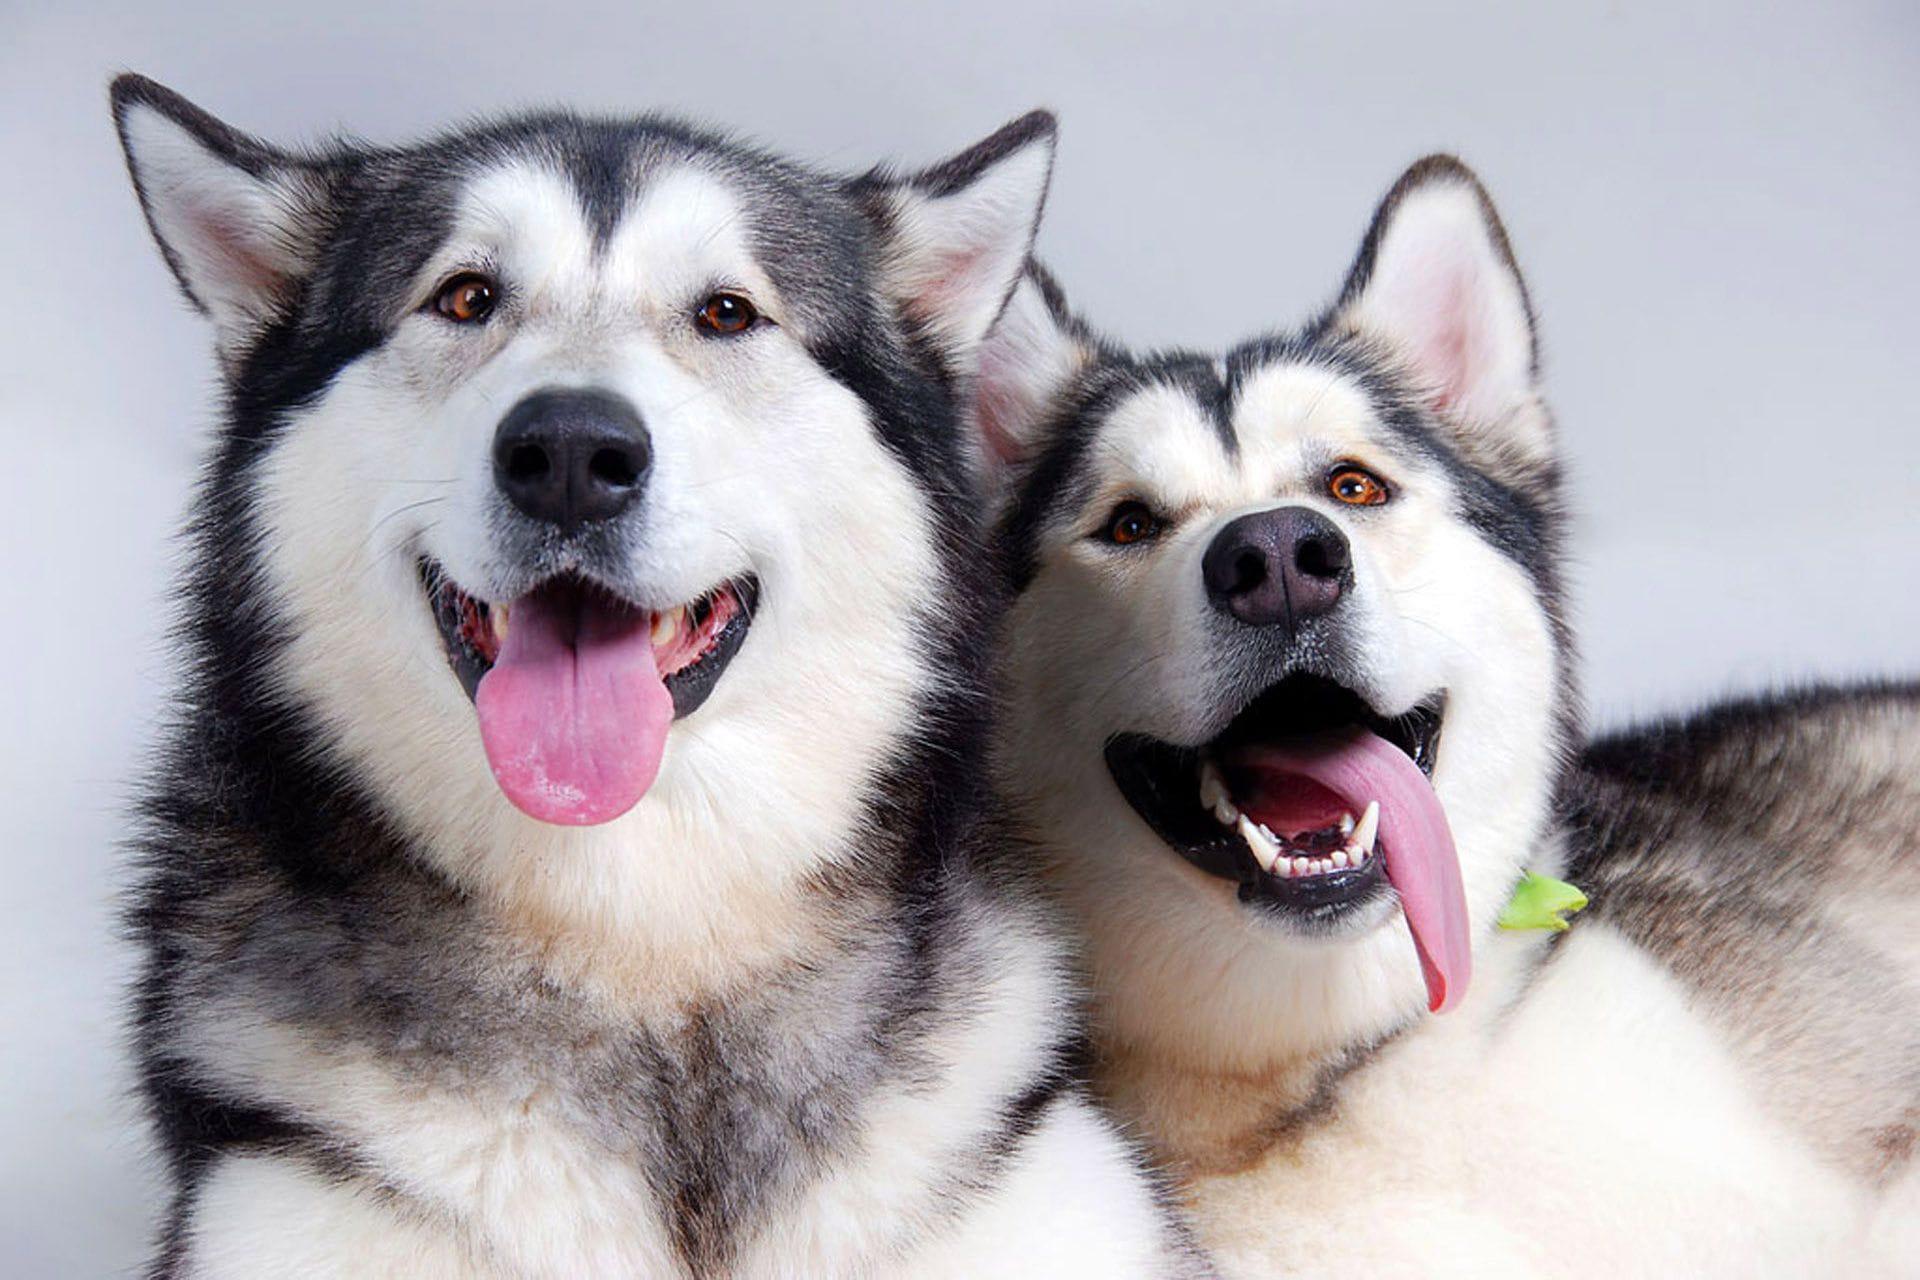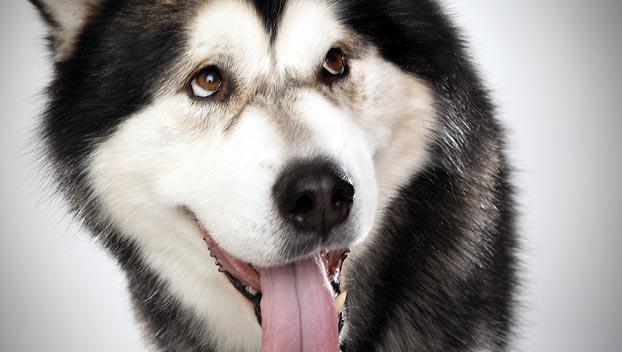The first image is the image on the left, the second image is the image on the right. Considering the images on both sides, is "Each image features only one dog, and the dog on the left has an open mouth, while the dog on the right has a closed mouth." valid? Answer yes or no. No. The first image is the image on the left, the second image is the image on the right. Analyze the images presented: Is the assertion "In the image to the right you can see the dog's tongue." valid? Answer yes or no. Yes. 